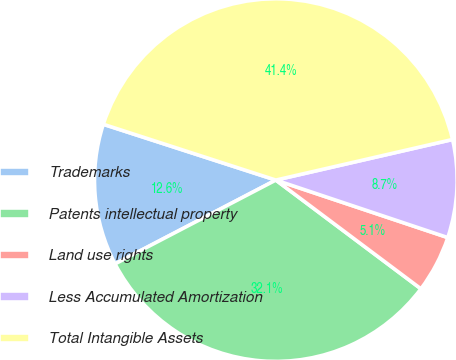<chart> <loc_0><loc_0><loc_500><loc_500><pie_chart><fcel>Trademarks<fcel>Patents intellectual property<fcel>Land use rights<fcel>Less Accumulated Amortization<fcel>Total Intangible Assets<nl><fcel>12.63%<fcel>32.12%<fcel>5.1%<fcel>8.73%<fcel>41.43%<nl></chart> 